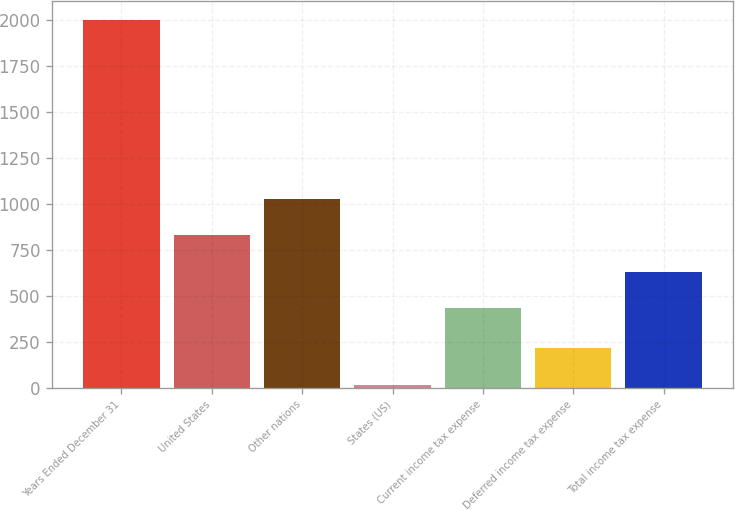Convert chart to OTSL. <chart><loc_0><loc_0><loc_500><loc_500><bar_chart><fcel>Years Ended December 31<fcel>United States<fcel>Other nations<fcel>States (US)<fcel>Current income tax expense<fcel>Deferred income tax expense<fcel>Total income tax expense<nl><fcel>2003<fcel>828.4<fcel>1027.1<fcel>16<fcel>431<fcel>214.7<fcel>629.7<nl></chart> 